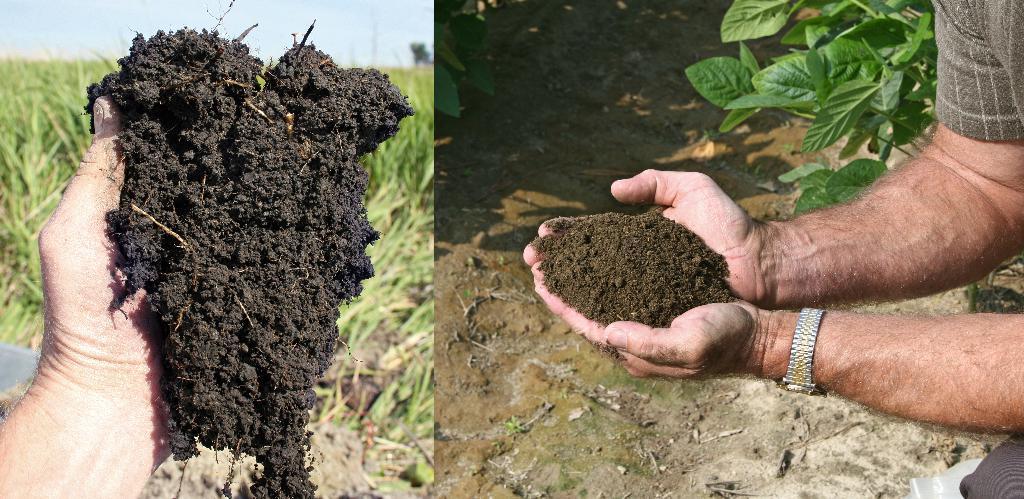How would you summarize this image in a sentence or two? We can see a collage image. There is an agricultural field at the left side of the image. We can see the sky at the left side of the image. We can see a person holding a mud in his hand at the both the sides of the photo. There is a plant at the right side of the image. 